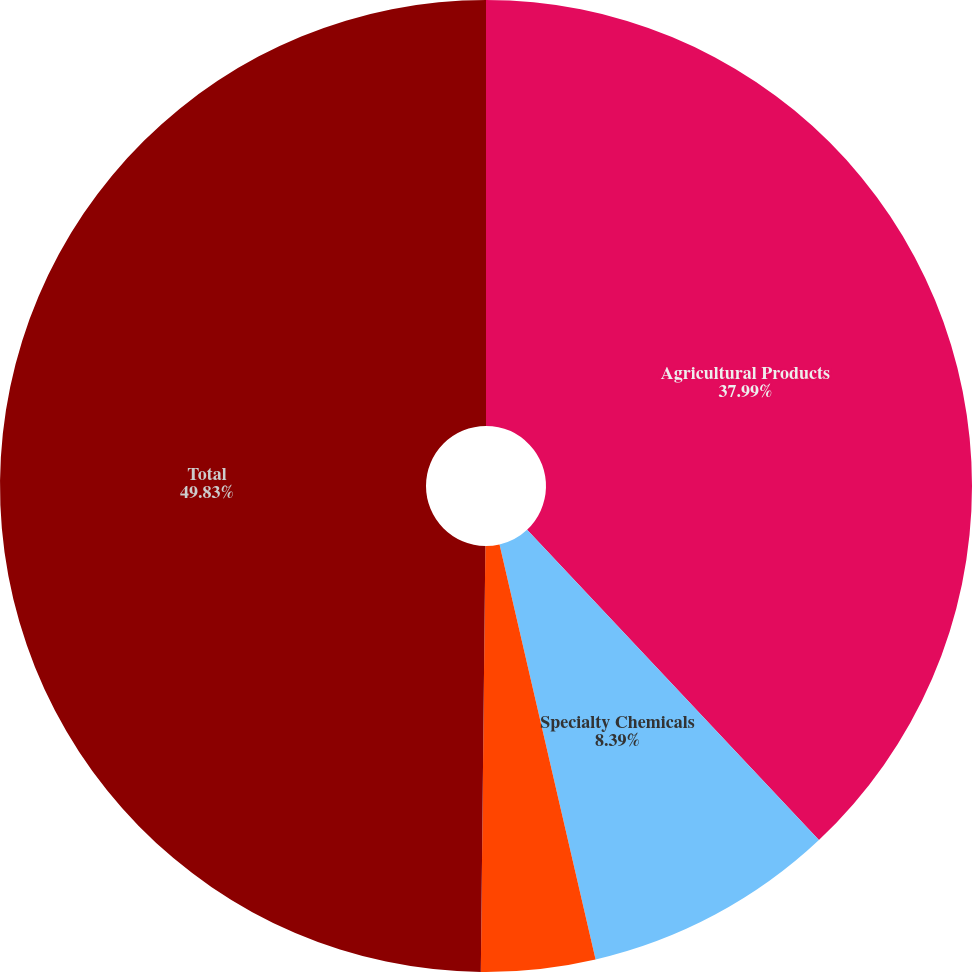<chart> <loc_0><loc_0><loc_500><loc_500><pie_chart><fcel>Agricultural Products<fcel>Specialty Chemicals<fcel>Industrial Chemicals<fcel>Total<nl><fcel>37.99%<fcel>8.39%<fcel>3.79%<fcel>49.83%<nl></chart> 